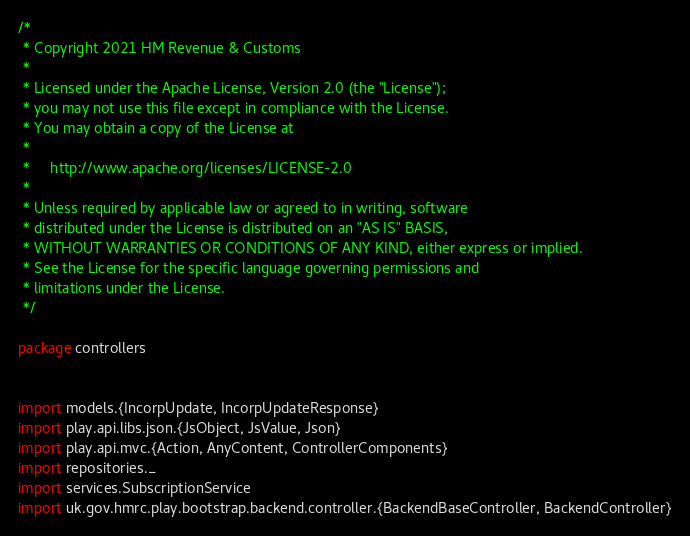Convert code to text. <code><loc_0><loc_0><loc_500><loc_500><_Scala_>/*
 * Copyright 2021 HM Revenue & Customs
 *
 * Licensed under the Apache License, Version 2.0 (the "License");
 * you may not use this file except in compliance with the License.
 * You may obtain a copy of the License at
 *
 *     http://www.apache.org/licenses/LICENSE-2.0
 *
 * Unless required by applicable law or agreed to in writing, software
 * distributed under the License is distributed on an "AS IS" BASIS,
 * WITHOUT WARRANTIES OR CONDITIONS OF ANY KIND, either express or implied.
 * See the License for the specific language governing permissions and
 * limitations under the License.
 */

package controllers


import models.{IncorpUpdate, IncorpUpdateResponse}
import play.api.libs.json.{JsObject, JsValue, Json}
import play.api.mvc.{Action, AnyContent, ControllerComponents}
import repositories._
import services.SubscriptionService
import uk.gov.hmrc.play.bootstrap.backend.controller.{BackendBaseController, BackendController}
</code> 